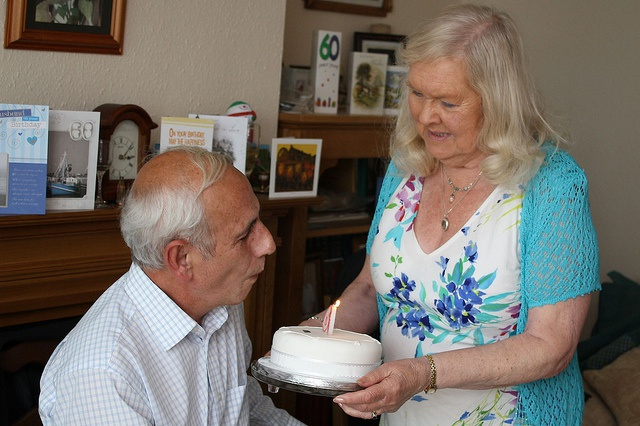Describe the objects in this image and their specific colors. I can see people in gray, tan, lightgray, and darkgray tones, people in gray, darkgray, lightgray, and brown tones, couch in gray, black, and teal tones, book in gray, lightblue, and darkgray tones, and cake in gray, lightgray, and darkgray tones in this image. 